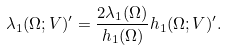Convert formula to latex. <formula><loc_0><loc_0><loc_500><loc_500>\lambda _ { 1 } ( \Omega ; V ) ^ { \prime } = \frac { 2 \lambda _ { 1 } ( \Omega ) } { h _ { 1 } ( \Omega ) } h _ { 1 } ( \Omega ; V ) ^ { \prime } .</formula> 